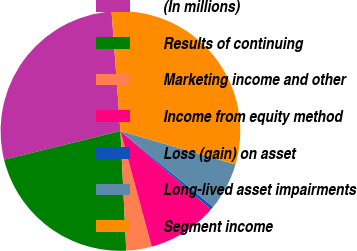Convert chart. <chart><loc_0><loc_0><loc_500><loc_500><pie_chart><fcel>(In millions)<fcel>Results of continuing<fcel>Marketing income and other<fcel>Income from equity method<fcel>Loss (gain) on asset<fcel>Long-lived asset impairments<fcel>Segment income<nl><fcel>27.68%<fcel>21.92%<fcel>3.43%<fcel>9.43%<fcel>0.43%<fcel>6.43%<fcel>30.68%<nl></chart> 